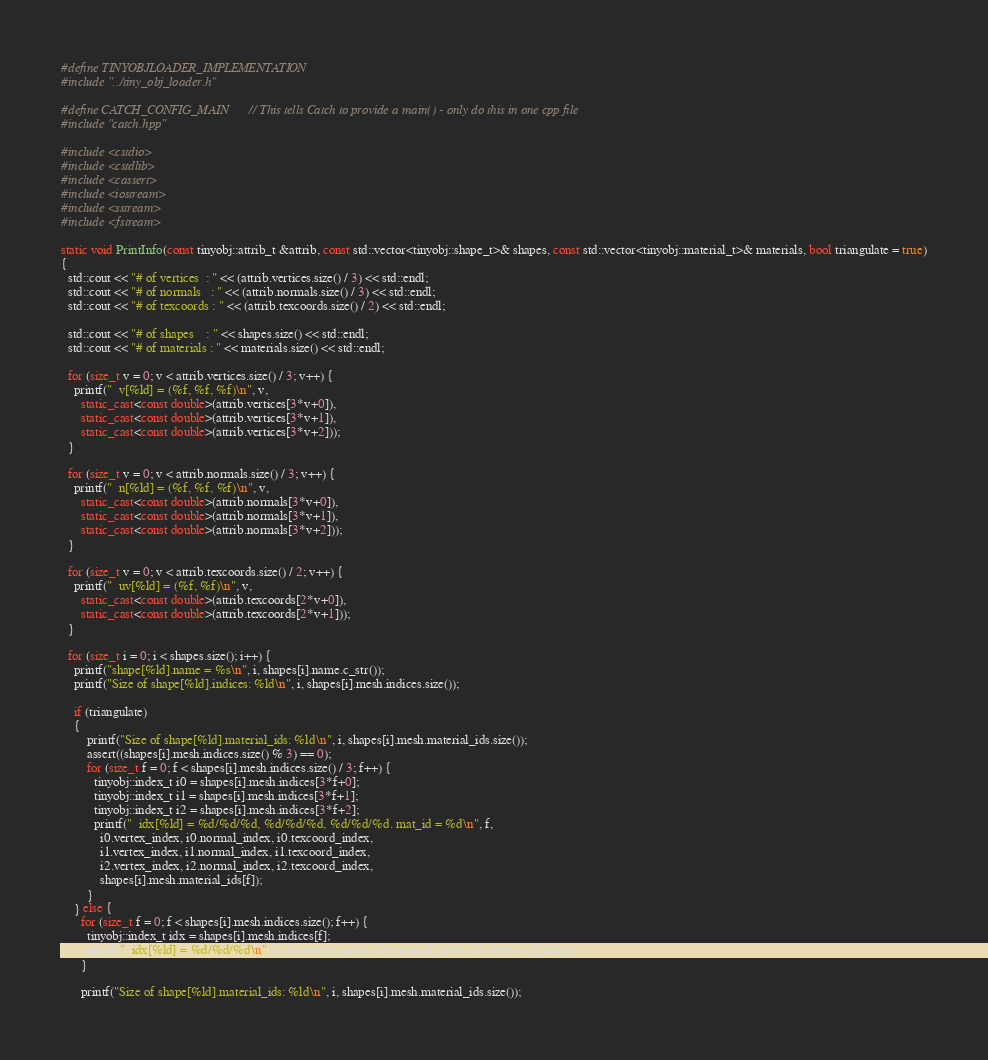Convert code to text. <code><loc_0><loc_0><loc_500><loc_500><_C++_>#define TINYOBJLOADER_IMPLEMENTATION
#include "../tiny_obj_loader.h"

#define CATCH_CONFIG_MAIN  // This tells Catch to provide a main() - only do this in one cpp file
#include "catch.hpp"

#include <cstdio>
#include <cstdlib>
#include <cassert>
#include <iostream>
#include <sstream>
#include <fstream>

static void PrintInfo(const tinyobj::attrib_t &attrib, const std::vector<tinyobj::shape_t>& shapes, const std::vector<tinyobj::material_t>& materials, bool triangulate = true)
{
  std::cout << "# of vertices  : " << (attrib.vertices.size() / 3) << std::endl;
  std::cout << "# of normals   : " << (attrib.normals.size() / 3) << std::endl;
  std::cout << "# of texcoords : " << (attrib.texcoords.size() / 2) << std::endl;

  std::cout << "# of shapes    : " << shapes.size() << std::endl;
  std::cout << "# of materials : " << materials.size() << std::endl;

  for (size_t v = 0; v < attrib.vertices.size() / 3; v++) {
    printf("  v[%ld] = (%f, %f, %f)\n", v,
      static_cast<const double>(attrib.vertices[3*v+0]),
      static_cast<const double>(attrib.vertices[3*v+1]),
      static_cast<const double>(attrib.vertices[3*v+2]));
  }

  for (size_t v = 0; v < attrib.normals.size() / 3; v++) {
    printf("  n[%ld] = (%f, %f, %f)\n", v,
      static_cast<const double>(attrib.normals[3*v+0]),
      static_cast<const double>(attrib.normals[3*v+1]),
      static_cast<const double>(attrib.normals[3*v+2]));
  }

  for (size_t v = 0; v < attrib.texcoords.size() / 2; v++) {
    printf("  uv[%ld] = (%f, %f)\n", v,
      static_cast<const double>(attrib.texcoords[2*v+0]),
      static_cast<const double>(attrib.texcoords[2*v+1]));
  }

  for (size_t i = 0; i < shapes.size(); i++) {
    printf("shape[%ld].name = %s\n", i, shapes[i].name.c_str());
    printf("Size of shape[%ld].indices: %ld\n", i, shapes[i].mesh.indices.size());

    if (triangulate)
    {
        printf("Size of shape[%ld].material_ids: %ld\n", i, shapes[i].mesh.material_ids.size());
        assert((shapes[i].mesh.indices.size() % 3) == 0);
        for (size_t f = 0; f < shapes[i].mesh.indices.size() / 3; f++) {
          tinyobj::index_t i0 = shapes[i].mesh.indices[3*f+0];
          tinyobj::index_t i1 = shapes[i].mesh.indices[3*f+1];
          tinyobj::index_t i2 = shapes[i].mesh.indices[3*f+2];
          printf("  idx[%ld] = %d/%d/%d, %d/%d/%d, %d/%d/%d. mat_id = %d\n", f,
            i0.vertex_index, i0.normal_index, i0.texcoord_index,
            i1.vertex_index, i1.normal_index, i1.texcoord_index,
            i2.vertex_index, i2.normal_index, i2.texcoord_index,
            shapes[i].mesh.material_ids[f]);
        }
    } else {
      for (size_t f = 0; f < shapes[i].mesh.indices.size(); f++) {
        tinyobj::index_t idx = shapes[i].mesh.indices[f];
        printf("  idx[%ld] = %d/%d/%d\n", f, idx.vertex_index, idx.normal_index, idx.texcoord_index);
      }

      printf("Size of shape[%ld].material_ids: %ld\n", i, shapes[i].mesh.material_ids.size());</code> 